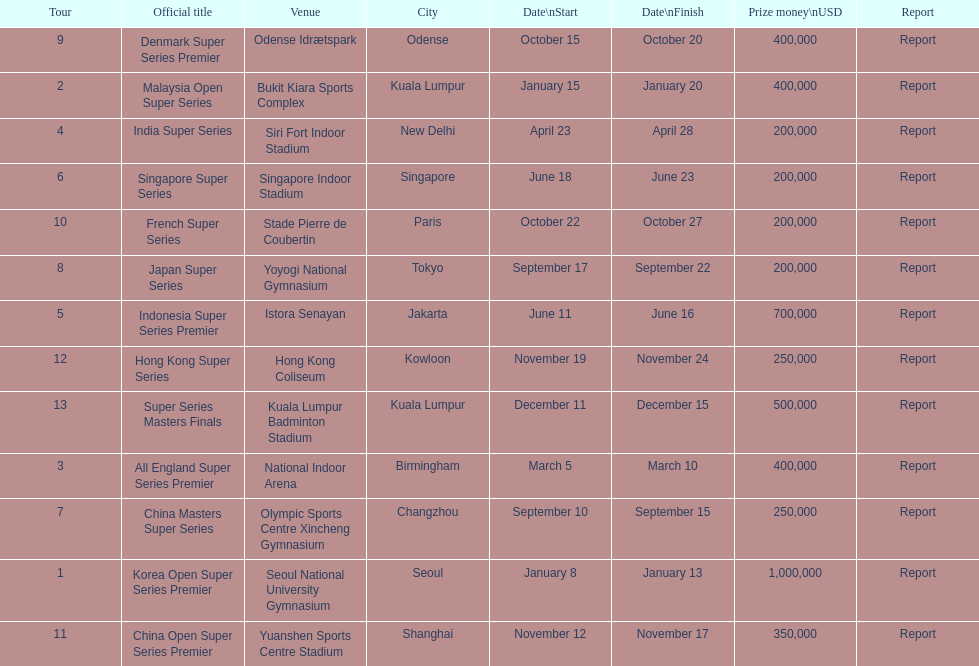How many series awarded at least $500,000 in prize money? 3. 